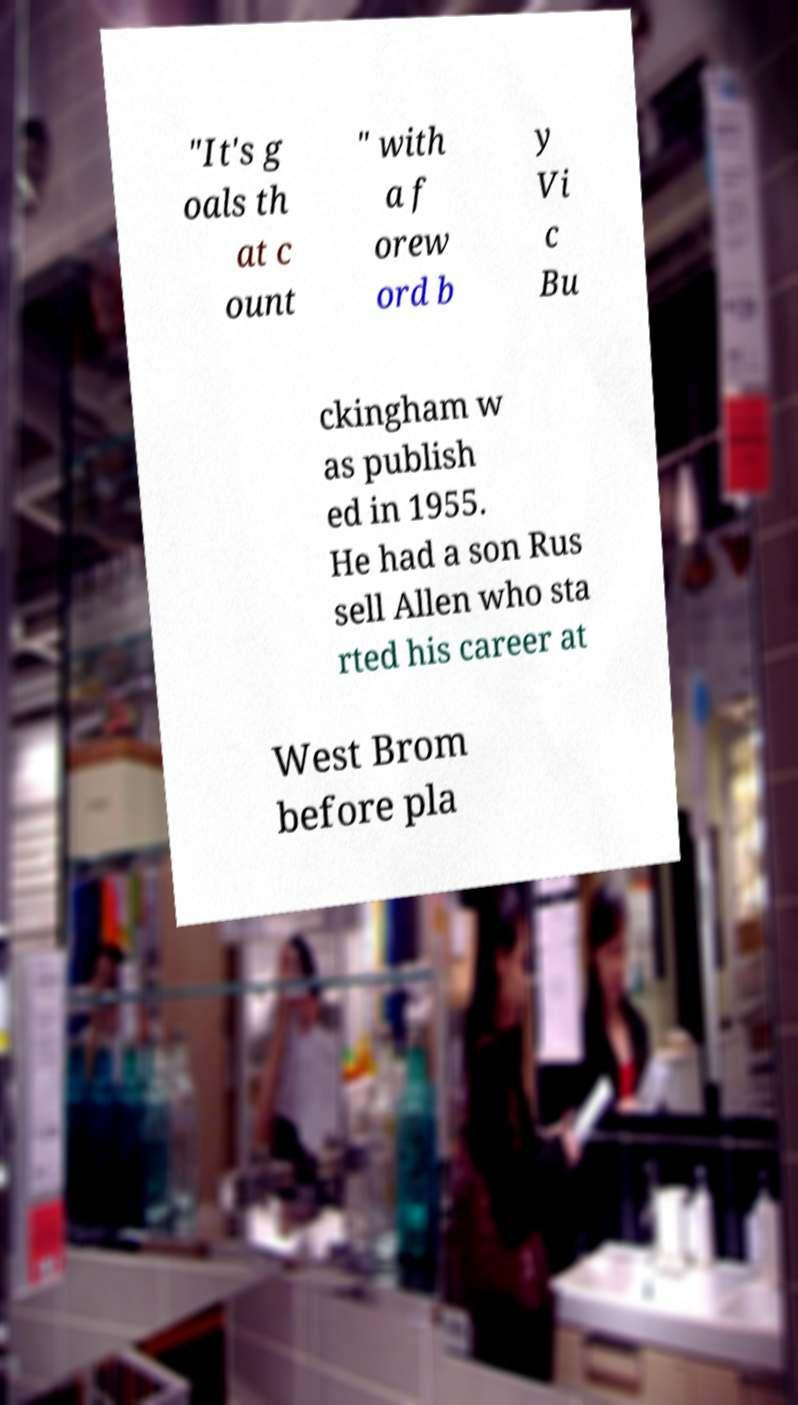Please identify and transcribe the text found in this image. "It's g oals th at c ount " with a f orew ord b y Vi c Bu ckingham w as publish ed in 1955. He had a son Rus sell Allen who sta rted his career at West Brom before pla 